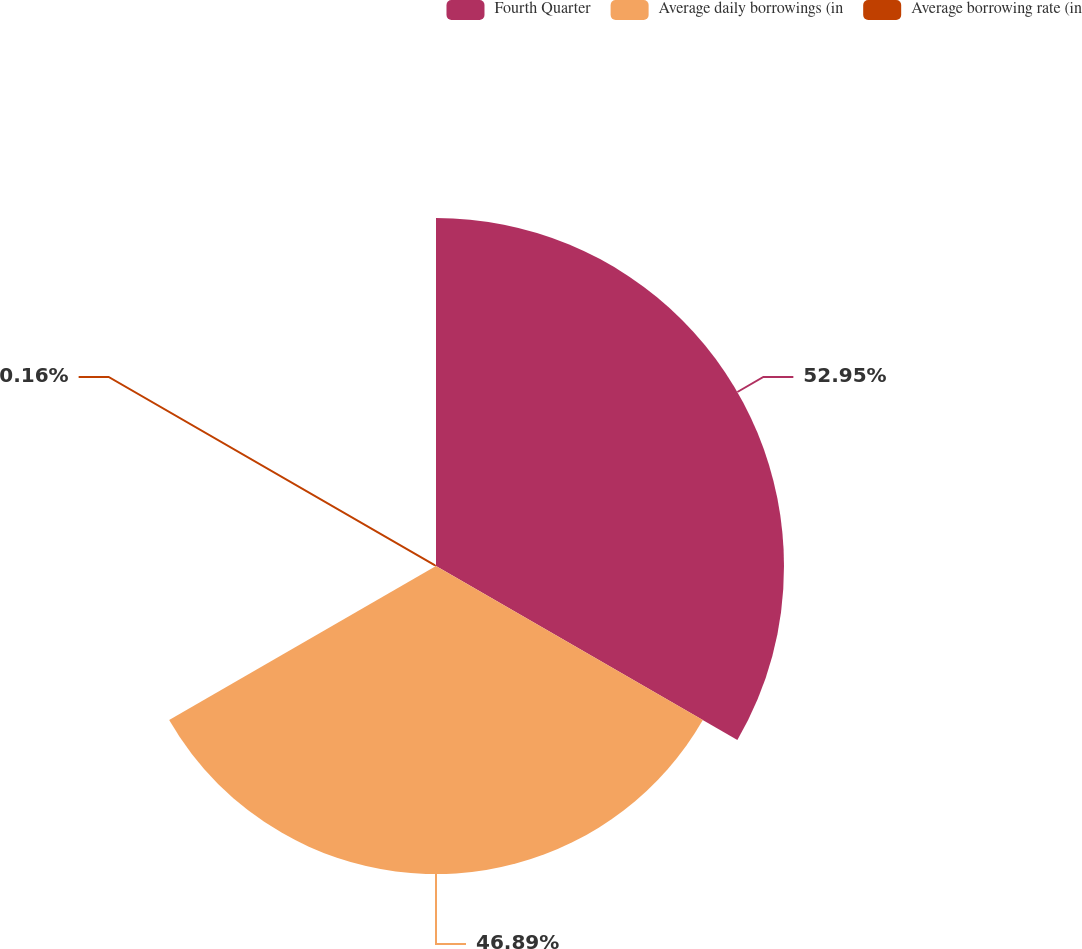<chart> <loc_0><loc_0><loc_500><loc_500><pie_chart><fcel>Fourth Quarter<fcel>Average daily borrowings (in<fcel>Average borrowing rate (in<nl><fcel>52.96%<fcel>46.89%<fcel>0.16%<nl></chart> 